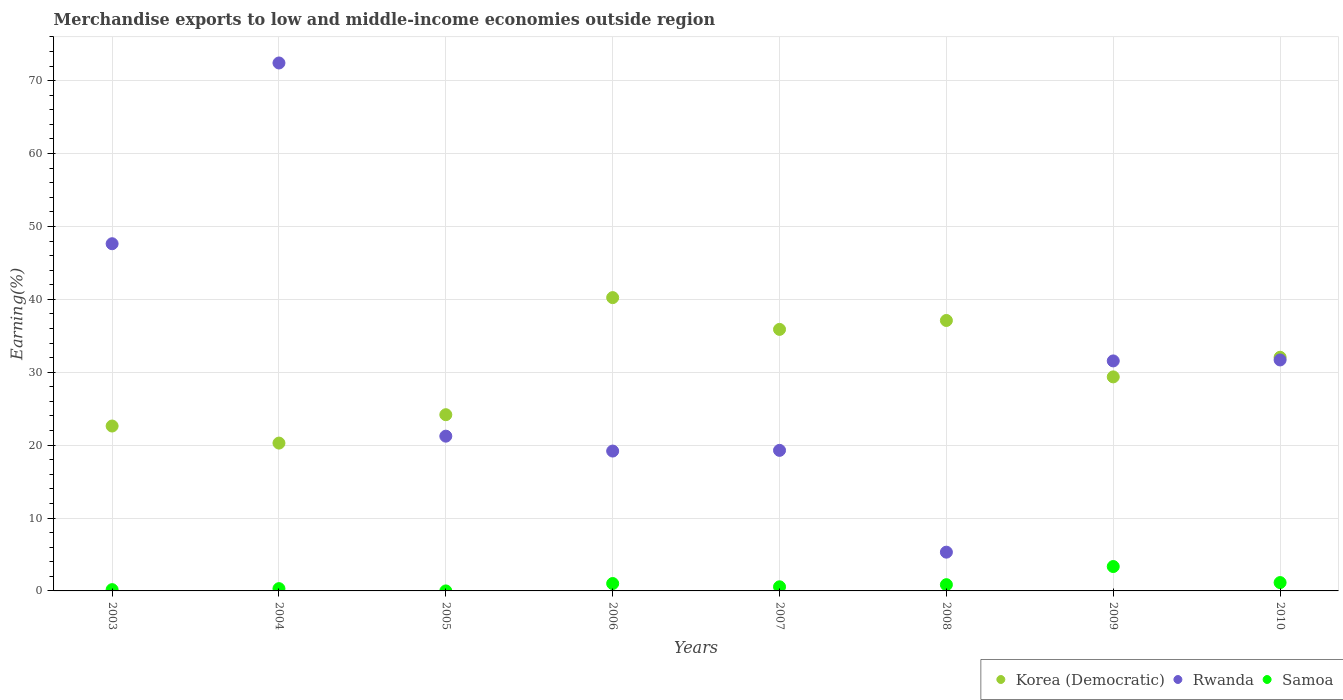How many different coloured dotlines are there?
Offer a very short reply. 3. Is the number of dotlines equal to the number of legend labels?
Give a very brief answer. Yes. What is the percentage of amount earned from merchandise exports in Samoa in 2008?
Give a very brief answer. 0.86. Across all years, what is the maximum percentage of amount earned from merchandise exports in Rwanda?
Offer a very short reply. 72.42. Across all years, what is the minimum percentage of amount earned from merchandise exports in Samoa?
Ensure brevity in your answer.  4.29047548765544e-6. In which year was the percentage of amount earned from merchandise exports in Korea (Democratic) maximum?
Give a very brief answer. 2006. In which year was the percentage of amount earned from merchandise exports in Korea (Democratic) minimum?
Offer a terse response. 2004. What is the total percentage of amount earned from merchandise exports in Samoa in the graph?
Provide a short and direct response. 7.41. What is the difference between the percentage of amount earned from merchandise exports in Rwanda in 2004 and that in 2008?
Make the answer very short. 67.11. What is the difference between the percentage of amount earned from merchandise exports in Samoa in 2004 and the percentage of amount earned from merchandise exports in Korea (Democratic) in 2007?
Your answer should be compact. -35.56. What is the average percentage of amount earned from merchandise exports in Korea (Democratic) per year?
Keep it short and to the point. 30.21. In the year 2006, what is the difference between the percentage of amount earned from merchandise exports in Samoa and percentage of amount earned from merchandise exports in Rwanda?
Your answer should be compact. -18.17. What is the ratio of the percentage of amount earned from merchandise exports in Rwanda in 2005 to that in 2007?
Your answer should be compact. 1.1. Is the percentage of amount earned from merchandise exports in Korea (Democratic) in 2003 less than that in 2010?
Your answer should be compact. Yes. Is the difference between the percentage of amount earned from merchandise exports in Samoa in 2005 and 2010 greater than the difference between the percentage of amount earned from merchandise exports in Rwanda in 2005 and 2010?
Your response must be concise. Yes. What is the difference between the highest and the second highest percentage of amount earned from merchandise exports in Korea (Democratic)?
Provide a short and direct response. 3.14. What is the difference between the highest and the lowest percentage of amount earned from merchandise exports in Rwanda?
Your answer should be compact. 67.11. In how many years, is the percentage of amount earned from merchandise exports in Korea (Democratic) greater than the average percentage of amount earned from merchandise exports in Korea (Democratic) taken over all years?
Offer a very short reply. 4. Is the percentage of amount earned from merchandise exports in Korea (Democratic) strictly greater than the percentage of amount earned from merchandise exports in Rwanda over the years?
Your answer should be compact. No. Is the percentage of amount earned from merchandise exports in Rwanda strictly less than the percentage of amount earned from merchandise exports in Samoa over the years?
Provide a short and direct response. No. Does the graph contain any zero values?
Give a very brief answer. No. Does the graph contain grids?
Ensure brevity in your answer.  Yes. How are the legend labels stacked?
Offer a terse response. Horizontal. What is the title of the graph?
Make the answer very short. Merchandise exports to low and middle-income economies outside region. Does "Malawi" appear as one of the legend labels in the graph?
Your answer should be compact. No. What is the label or title of the X-axis?
Provide a succinct answer. Years. What is the label or title of the Y-axis?
Your answer should be compact. Earning(%). What is the Earning(%) in Korea (Democratic) in 2003?
Offer a very short reply. 22.62. What is the Earning(%) of Rwanda in 2003?
Provide a short and direct response. 47.63. What is the Earning(%) of Samoa in 2003?
Your response must be concise. 0.18. What is the Earning(%) of Korea (Democratic) in 2004?
Make the answer very short. 20.28. What is the Earning(%) of Rwanda in 2004?
Provide a short and direct response. 72.42. What is the Earning(%) of Samoa in 2004?
Give a very brief answer. 0.31. What is the Earning(%) of Korea (Democratic) in 2005?
Provide a short and direct response. 24.17. What is the Earning(%) in Rwanda in 2005?
Ensure brevity in your answer.  21.23. What is the Earning(%) in Samoa in 2005?
Ensure brevity in your answer.  4.29047548765544e-6. What is the Earning(%) of Korea (Democratic) in 2006?
Your response must be concise. 40.24. What is the Earning(%) in Rwanda in 2006?
Provide a succinct answer. 19.19. What is the Earning(%) of Samoa in 2006?
Your answer should be compact. 1.01. What is the Earning(%) in Korea (Democratic) in 2007?
Make the answer very short. 35.88. What is the Earning(%) of Rwanda in 2007?
Give a very brief answer. 19.28. What is the Earning(%) in Samoa in 2007?
Ensure brevity in your answer.  0.57. What is the Earning(%) in Korea (Democratic) in 2008?
Your response must be concise. 37.1. What is the Earning(%) of Rwanda in 2008?
Make the answer very short. 5.32. What is the Earning(%) in Samoa in 2008?
Ensure brevity in your answer.  0.86. What is the Earning(%) of Korea (Democratic) in 2009?
Keep it short and to the point. 29.36. What is the Earning(%) of Rwanda in 2009?
Ensure brevity in your answer.  31.55. What is the Earning(%) of Samoa in 2009?
Ensure brevity in your answer.  3.35. What is the Earning(%) in Korea (Democratic) in 2010?
Provide a short and direct response. 32.05. What is the Earning(%) in Rwanda in 2010?
Offer a very short reply. 31.68. What is the Earning(%) in Samoa in 2010?
Make the answer very short. 1.14. Across all years, what is the maximum Earning(%) in Korea (Democratic)?
Offer a terse response. 40.24. Across all years, what is the maximum Earning(%) of Rwanda?
Offer a terse response. 72.42. Across all years, what is the maximum Earning(%) of Samoa?
Give a very brief answer. 3.35. Across all years, what is the minimum Earning(%) of Korea (Democratic)?
Offer a very short reply. 20.28. Across all years, what is the minimum Earning(%) in Rwanda?
Ensure brevity in your answer.  5.32. Across all years, what is the minimum Earning(%) in Samoa?
Keep it short and to the point. 4.29047548765544e-6. What is the total Earning(%) of Korea (Democratic) in the graph?
Make the answer very short. 241.7. What is the total Earning(%) of Rwanda in the graph?
Keep it short and to the point. 248.3. What is the total Earning(%) of Samoa in the graph?
Give a very brief answer. 7.41. What is the difference between the Earning(%) in Korea (Democratic) in 2003 and that in 2004?
Make the answer very short. 2.34. What is the difference between the Earning(%) of Rwanda in 2003 and that in 2004?
Offer a terse response. -24.8. What is the difference between the Earning(%) in Samoa in 2003 and that in 2004?
Provide a succinct answer. -0.14. What is the difference between the Earning(%) in Korea (Democratic) in 2003 and that in 2005?
Give a very brief answer. -1.55. What is the difference between the Earning(%) in Rwanda in 2003 and that in 2005?
Give a very brief answer. 26.4. What is the difference between the Earning(%) in Samoa in 2003 and that in 2005?
Provide a short and direct response. 0.18. What is the difference between the Earning(%) of Korea (Democratic) in 2003 and that in 2006?
Your answer should be compact. -17.62. What is the difference between the Earning(%) of Rwanda in 2003 and that in 2006?
Provide a short and direct response. 28.44. What is the difference between the Earning(%) in Samoa in 2003 and that in 2006?
Give a very brief answer. -0.84. What is the difference between the Earning(%) of Korea (Democratic) in 2003 and that in 2007?
Give a very brief answer. -13.26. What is the difference between the Earning(%) of Rwanda in 2003 and that in 2007?
Offer a terse response. 28.35. What is the difference between the Earning(%) of Samoa in 2003 and that in 2007?
Offer a very short reply. -0.39. What is the difference between the Earning(%) in Korea (Democratic) in 2003 and that in 2008?
Make the answer very short. -14.48. What is the difference between the Earning(%) of Rwanda in 2003 and that in 2008?
Give a very brief answer. 42.31. What is the difference between the Earning(%) in Samoa in 2003 and that in 2008?
Your response must be concise. -0.68. What is the difference between the Earning(%) in Korea (Democratic) in 2003 and that in 2009?
Make the answer very short. -6.74. What is the difference between the Earning(%) in Rwanda in 2003 and that in 2009?
Keep it short and to the point. 16.08. What is the difference between the Earning(%) in Samoa in 2003 and that in 2009?
Provide a short and direct response. -3.17. What is the difference between the Earning(%) of Korea (Democratic) in 2003 and that in 2010?
Your answer should be compact. -9.43. What is the difference between the Earning(%) of Rwanda in 2003 and that in 2010?
Offer a very short reply. 15.94. What is the difference between the Earning(%) of Samoa in 2003 and that in 2010?
Provide a succinct answer. -0.97. What is the difference between the Earning(%) of Korea (Democratic) in 2004 and that in 2005?
Your answer should be very brief. -3.89. What is the difference between the Earning(%) of Rwanda in 2004 and that in 2005?
Your response must be concise. 51.19. What is the difference between the Earning(%) in Samoa in 2004 and that in 2005?
Ensure brevity in your answer.  0.31. What is the difference between the Earning(%) in Korea (Democratic) in 2004 and that in 2006?
Keep it short and to the point. -19.96. What is the difference between the Earning(%) in Rwanda in 2004 and that in 2006?
Your response must be concise. 53.24. What is the difference between the Earning(%) in Samoa in 2004 and that in 2006?
Ensure brevity in your answer.  -0.7. What is the difference between the Earning(%) in Korea (Democratic) in 2004 and that in 2007?
Your answer should be very brief. -15.6. What is the difference between the Earning(%) in Rwanda in 2004 and that in 2007?
Keep it short and to the point. 53.14. What is the difference between the Earning(%) in Samoa in 2004 and that in 2007?
Offer a terse response. -0.25. What is the difference between the Earning(%) of Korea (Democratic) in 2004 and that in 2008?
Give a very brief answer. -16.82. What is the difference between the Earning(%) of Rwanda in 2004 and that in 2008?
Give a very brief answer. 67.11. What is the difference between the Earning(%) in Samoa in 2004 and that in 2008?
Keep it short and to the point. -0.54. What is the difference between the Earning(%) of Korea (Democratic) in 2004 and that in 2009?
Ensure brevity in your answer.  -9.08. What is the difference between the Earning(%) in Rwanda in 2004 and that in 2009?
Make the answer very short. 40.87. What is the difference between the Earning(%) in Samoa in 2004 and that in 2009?
Make the answer very short. -3.03. What is the difference between the Earning(%) in Korea (Democratic) in 2004 and that in 2010?
Provide a short and direct response. -11.77. What is the difference between the Earning(%) in Rwanda in 2004 and that in 2010?
Provide a short and direct response. 40.74. What is the difference between the Earning(%) in Samoa in 2004 and that in 2010?
Make the answer very short. -0.83. What is the difference between the Earning(%) in Korea (Democratic) in 2005 and that in 2006?
Your response must be concise. -16.06. What is the difference between the Earning(%) of Rwanda in 2005 and that in 2006?
Keep it short and to the point. 2.04. What is the difference between the Earning(%) of Samoa in 2005 and that in 2006?
Keep it short and to the point. -1.01. What is the difference between the Earning(%) of Korea (Democratic) in 2005 and that in 2007?
Ensure brevity in your answer.  -11.7. What is the difference between the Earning(%) in Rwanda in 2005 and that in 2007?
Provide a short and direct response. 1.95. What is the difference between the Earning(%) of Samoa in 2005 and that in 2007?
Provide a succinct answer. -0.57. What is the difference between the Earning(%) of Korea (Democratic) in 2005 and that in 2008?
Your response must be concise. -12.93. What is the difference between the Earning(%) in Rwanda in 2005 and that in 2008?
Make the answer very short. 15.91. What is the difference between the Earning(%) of Samoa in 2005 and that in 2008?
Provide a short and direct response. -0.86. What is the difference between the Earning(%) of Korea (Democratic) in 2005 and that in 2009?
Provide a short and direct response. -5.19. What is the difference between the Earning(%) of Rwanda in 2005 and that in 2009?
Your response must be concise. -10.32. What is the difference between the Earning(%) of Samoa in 2005 and that in 2009?
Give a very brief answer. -3.35. What is the difference between the Earning(%) of Korea (Democratic) in 2005 and that in 2010?
Make the answer very short. -7.88. What is the difference between the Earning(%) in Rwanda in 2005 and that in 2010?
Your response must be concise. -10.46. What is the difference between the Earning(%) in Samoa in 2005 and that in 2010?
Offer a terse response. -1.14. What is the difference between the Earning(%) of Korea (Democratic) in 2006 and that in 2007?
Ensure brevity in your answer.  4.36. What is the difference between the Earning(%) in Rwanda in 2006 and that in 2007?
Offer a very short reply. -0.1. What is the difference between the Earning(%) of Samoa in 2006 and that in 2007?
Provide a short and direct response. 0.45. What is the difference between the Earning(%) in Korea (Democratic) in 2006 and that in 2008?
Ensure brevity in your answer.  3.14. What is the difference between the Earning(%) in Rwanda in 2006 and that in 2008?
Offer a terse response. 13.87. What is the difference between the Earning(%) of Samoa in 2006 and that in 2008?
Provide a short and direct response. 0.16. What is the difference between the Earning(%) in Korea (Democratic) in 2006 and that in 2009?
Offer a terse response. 10.87. What is the difference between the Earning(%) in Rwanda in 2006 and that in 2009?
Ensure brevity in your answer.  -12.37. What is the difference between the Earning(%) of Samoa in 2006 and that in 2009?
Your answer should be compact. -2.33. What is the difference between the Earning(%) of Korea (Democratic) in 2006 and that in 2010?
Offer a very short reply. 8.19. What is the difference between the Earning(%) of Rwanda in 2006 and that in 2010?
Give a very brief answer. -12.5. What is the difference between the Earning(%) in Samoa in 2006 and that in 2010?
Your answer should be compact. -0.13. What is the difference between the Earning(%) in Korea (Democratic) in 2007 and that in 2008?
Provide a short and direct response. -1.22. What is the difference between the Earning(%) of Rwanda in 2007 and that in 2008?
Make the answer very short. 13.96. What is the difference between the Earning(%) in Samoa in 2007 and that in 2008?
Your answer should be compact. -0.29. What is the difference between the Earning(%) in Korea (Democratic) in 2007 and that in 2009?
Make the answer very short. 6.52. What is the difference between the Earning(%) in Rwanda in 2007 and that in 2009?
Give a very brief answer. -12.27. What is the difference between the Earning(%) in Samoa in 2007 and that in 2009?
Provide a succinct answer. -2.78. What is the difference between the Earning(%) in Korea (Democratic) in 2007 and that in 2010?
Offer a very short reply. 3.83. What is the difference between the Earning(%) of Rwanda in 2007 and that in 2010?
Your answer should be very brief. -12.4. What is the difference between the Earning(%) in Samoa in 2007 and that in 2010?
Offer a very short reply. -0.58. What is the difference between the Earning(%) in Korea (Democratic) in 2008 and that in 2009?
Give a very brief answer. 7.74. What is the difference between the Earning(%) of Rwanda in 2008 and that in 2009?
Provide a succinct answer. -26.23. What is the difference between the Earning(%) of Samoa in 2008 and that in 2009?
Give a very brief answer. -2.49. What is the difference between the Earning(%) of Korea (Democratic) in 2008 and that in 2010?
Keep it short and to the point. 5.05. What is the difference between the Earning(%) in Rwanda in 2008 and that in 2010?
Make the answer very short. -26.37. What is the difference between the Earning(%) of Samoa in 2008 and that in 2010?
Provide a succinct answer. -0.29. What is the difference between the Earning(%) of Korea (Democratic) in 2009 and that in 2010?
Your response must be concise. -2.69. What is the difference between the Earning(%) of Rwanda in 2009 and that in 2010?
Make the answer very short. -0.13. What is the difference between the Earning(%) in Samoa in 2009 and that in 2010?
Provide a short and direct response. 2.2. What is the difference between the Earning(%) of Korea (Democratic) in 2003 and the Earning(%) of Rwanda in 2004?
Your answer should be very brief. -49.8. What is the difference between the Earning(%) in Korea (Democratic) in 2003 and the Earning(%) in Samoa in 2004?
Offer a terse response. 22.31. What is the difference between the Earning(%) of Rwanda in 2003 and the Earning(%) of Samoa in 2004?
Keep it short and to the point. 47.31. What is the difference between the Earning(%) in Korea (Democratic) in 2003 and the Earning(%) in Rwanda in 2005?
Your answer should be compact. 1.39. What is the difference between the Earning(%) in Korea (Democratic) in 2003 and the Earning(%) in Samoa in 2005?
Your response must be concise. 22.62. What is the difference between the Earning(%) in Rwanda in 2003 and the Earning(%) in Samoa in 2005?
Your response must be concise. 47.63. What is the difference between the Earning(%) of Korea (Democratic) in 2003 and the Earning(%) of Rwanda in 2006?
Provide a short and direct response. 3.43. What is the difference between the Earning(%) in Korea (Democratic) in 2003 and the Earning(%) in Samoa in 2006?
Offer a very short reply. 21.61. What is the difference between the Earning(%) of Rwanda in 2003 and the Earning(%) of Samoa in 2006?
Your response must be concise. 46.61. What is the difference between the Earning(%) of Korea (Democratic) in 2003 and the Earning(%) of Rwanda in 2007?
Your answer should be compact. 3.34. What is the difference between the Earning(%) in Korea (Democratic) in 2003 and the Earning(%) in Samoa in 2007?
Offer a terse response. 22.05. What is the difference between the Earning(%) in Rwanda in 2003 and the Earning(%) in Samoa in 2007?
Your answer should be very brief. 47.06. What is the difference between the Earning(%) of Korea (Democratic) in 2003 and the Earning(%) of Rwanda in 2008?
Ensure brevity in your answer.  17.3. What is the difference between the Earning(%) of Korea (Democratic) in 2003 and the Earning(%) of Samoa in 2008?
Offer a very short reply. 21.76. What is the difference between the Earning(%) of Rwanda in 2003 and the Earning(%) of Samoa in 2008?
Provide a succinct answer. 46.77. What is the difference between the Earning(%) of Korea (Democratic) in 2003 and the Earning(%) of Rwanda in 2009?
Provide a succinct answer. -8.93. What is the difference between the Earning(%) in Korea (Democratic) in 2003 and the Earning(%) in Samoa in 2009?
Your answer should be compact. 19.27. What is the difference between the Earning(%) of Rwanda in 2003 and the Earning(%) of Samoa in 2009?
Make the answer very short. 44.28. What is the difference between the Earning(%) of Korea (Democratic) in 2003 and the Earning(%) of Rwanda in 2010?
Your response must be concise. -9.06. What is the difference between the Earning(%) in Korea (Democratic) in 2003 and the Earning(%) in Samoa in 2010?
Your response must be concise. 21.48. What is the difference between the Earning(%) of Rwanda in 2003 and the Earning(%) of Samoa in 2010?
Your response must be concise. 46.48. What is the difference between the Earning(%) in Korea (Democratic) in 2004 and the Earning(%) in Rwanda in 2005?
Provide a short and direct response. -0.95. What is the difference between the Earning(%) in Korea (Democratic) in 2004 and the Earning(%) in Samoa in 2005?
Provide a short and direct response. 20.28. What is the difference between the Earning(%) of Rwanda in 2004 and the Earning(%) of Samoa in 2005?
Make the answer very short. 72.42. What is the difference between the Earning(%) in Korea (Democratic) in 2004 and the Earning(%) in Rwanda in 2006?
Provide a succinct answer. 1.09. What is the difference between the Earning(%) in Korea (Democratic) in 2004 and the Earning(%) in Samoa in 2006?
Ensure brevity in your answer.  19.27. What is the difference between the Earning(%) of Rwanda in 2004 and the Earning(%) of Samoa in 2006?
Your answer should be very brief. 71.41. What is the difference between the Earning(%) of Korea (Democratic) in 2004 and the Earning(%) of Rwanda in 2007?
Offer a terse response. 1. What is the difference between the Earning(%) in Korea (Democratic) in 2004 and the Earning(%) in Samoa in 2007?
Your response must be concise. 19.71. What is the difference between the Earning(%) of Rwanda in 2004 and the Earning(%) of Samoa in 2007?
Provide a succinct answer. 71.86. What is the difference between the Earning(%) in Korea (Democratic) in 2004 and the Earning(%) in Rwanda in 2008?
Your response must be concise. 14.96. What is the difference between the Earning(%) of Korea (Democratic) in 2004 and the Earning(%) of Samoa in 2008?
Provide a succinct answer. 19.42. What is the difference between the Earning(%) of Rwanda in 2004 and the Earning(%) of Samoa in 2008?
Make the answer very short. 71.57. What is the difference between the Earning(%) of Korea (Democratic) in 2004 and the Earning(%) of Rwanda in 2009?
Provide a succinct answer. -11.27. What is the difference between the Earning(%) in Korea (Democratic) in 2004 and the Earning(%) in Samoa in 2009?
Make the answer very short. 16.93. What is the difference between the Earning(%) in Rwanda in 2004 and the Earning(%) in Samoa in 2009?
Keep it short and to the point. 69.08. What is the difference between the Earning(%) of Korea (Democratic) in 2004 and the Earning(%) of Rwanda in 2010?
Make the answer very short. -11.41. What is the difference between the Earning(%) of Korea (Democratic) in 2004 and the Earning(%) of Samoa in 2010?
Ensure brevity in your answer.  19.13. What is the difference between the Earning(%) in Rwanda in 2004 and the Earning(%) in Samoa in 2010?
Ensure brevity in your answer.  71.28. What is the difference between the Earning(%) of Korea (Democratic) in 2005 and the Earning(%) of Rwanda in 2006?
Offer a terse response. 4.99. What is the difference between the Earning(%) in Korea (Democratic) in 2005 and the Earning(%) in Samoa in 2006?
Keep it short and to the point. 23.16. What is the difference between the Earning(%) in Rwanda in 2005 and the Earning(%) in Samoa in 2006?
Your answer should be very brief. 20.22. What is the difference between the Earning(%) in Korea (Democratic) in 2005 and the Earning(%) in Rwanda in 2007?
Make the answer very short. 4.89. What is the difference between the Earning(%) in Korea (Democratic) in 2005 and the Earning(%) in Samoa in 2007?
Make the answer very short. 23.61. What is the difference between the Earning(%) in Rwanda in 2005 and the Earning(%) in Samoa in 2007?
Make the answer very short. 20.66. What is the difference between the Earning(%) of Korea (Democratic) in 2005 and the Earning(%) of Rwanda in 2008?
Your answer should be very brief. 18.86. What is the difference between the Earning(%) of Korea (Democratic) in 2005 and the Earning(%) of Samoa in 2008?
Make the answer very short. 23.32. What is the difference between the Earning(%) in Rwanda in 2005 and the Earning(%) in Samoa in 2008?
Your answer should be very brief. 20.37. What is the difference between the Earning(%) in Korea (Democratic) in 2005 and the Earning(%) in Rwanda in 2009?
Give a very brief answer. -7.38. What is the difference between the Earning(%) of Korea (Democratic) in 2005 and the Earning(%) of Samoa in 2009?
Make the answer very short. 20.83. What is the difference between the Earning(%) of Rwanda in 2005 and the Earning(%) of Samoa in 2009?
Keep it short and to the point. 17.88. What is the difference between the Earning(%) in Korea (Democratic) in 2005 and the Earning(%) in Rwanda in 2010?
Make the answer very short. -7.51. What is the difference between the Earning(%) in Korea (Democratic) in 2005 and the Earning(%) in Samoa in 2010?
Make the answer very short. 23.03. What is the difference between the Earning(%) in Rwanda in 2005 and the Earning(%) in Samoa in 2010?
Offer a very short reply. 20.09. What is the difference between the Earning(%) of Korea (Democratic) in 2006 and the Earning(%) of Rwanda in 2007?
Make the answer very short. 20.95. What is the difference between the Earning(%) of Korea (Democratic) in 2006 and the Earning(%) of Samoa in 2007?
Offer a very short reply. 39.67. What is the difference between the Earning(%) in Rwanda in 2006 and the Earning(%) in Samoa in 2007?
Keep it short and to the point. 18.62. What is the difference between the Earning(%) of Korea (Democratic) in 2006 and the Earning(%) of Rwanda in 2008?
Provide a succinct answer. 34.92. What is the difference between the Earning(%) of Korea (Democratic) in 2006 and the Earning(%) of Samoa in 2008?
Provide a succinct answer. 39.38. What is the difference between the Earning(%) in Rwanda in 2006 and the Earning(%) in Samoa in 2008?
Ensure brevity in your answer.  18.33. What is the difference between the Earning(%) in Korea (Democratic) in 2006 and the Earning(%) in Rwanda in 2009?
Ensure brevity in your answer.  8.68. What is the difference between the Earning(%) in Korea (Democratic) in 2006 and the Earning(%) in Samoa in 2009?
Your answer should be compact. 36.89. What is the difference between the Earning(%) in Rwanda in 2006 and the Earning(%) in Samoa in 2009?
Make the answer very short. 15.84. What is the difference between the Earning(%) of Korea (Democratic) in 2006 and the Earning(%) of Rwanda in 2010?
Make the answer very short. 8.55. What is the difference between the Earning(%) of Korea (Democratic) in 2006 and the Earning(%) of Samoa in 2010?
Your answer should be very brief. 39.09. What is the difference between the Earning(%) of Rwanda in 2006 and the Earning(%) of Samoa in 2010?
Provide a short and direct response. 18.04. What is the difference between the Earning(%) of Korea (Democratic) in 2007 and the Earning(%) of Rwanda in 2008?
Your answer should be compact. 30.56. What is the difference between the Earning(%) of Korea (Democratic) in 2007 and the Earning(%) of Samoa in 2008?
Make the answer very short. 35.02. What is the difference between the Earning(%) of Rwanda in 2007 and the Earning(%) of Samoa in 2008?
Your response must be concise. 18.43. What is the difference between the Earning(%) of Korea (Democratic) in 2007 and the Earning(%) of Rwanda in 2009?
Keep it short and to the point. 4.33. What is the difference between the Earning(%) in Korea (Democratic) in 2007 and the Earning(%) in Samoa in 2009?
Offer a very short reply. 32.53. What is the difference between the Earning(%) in Rwanda in 2007 and the Earning(%) in Samoa in 2009?
Your answer should be compact. 15.94. What is the difference between the Earning(%) in Korea (Democratic) in 2007 and the Earning(%) in Rwanda in 2010?
Keep it short and to the point. 4.19. What is the difference between the Earning(%) in Korea (Democratic) in 2007 and the Earning(%) in Samoa in 2010?
Your answer should be very brief. 34.73. What is the difference between the Earning(%) in Rwanda in 2007 and the Earning(%) in Samoa in 2010?
Ensure brevity in your answer.  18.14. What is the difference between the Earning(%) in Korea (Democratic) in 2008 and the Earning(%) in Rwanda in 2009?
Your answer should be compact. 5.55. What is the difference between the Earning(%) in Korea (Democratic) in 2008 and the Earning(%) in Samoa in 2009?
Your answer should be compact. 33.75. What is the difference between the Earning(%) of Rwanda in 2008 and the Earning(%) of Samoa in 2009?
Give a very brief answer. 1.97. What is the difference between the Earning(%) of Korea (Democratic) in 2008 and the Earning(%) of Rwanda in 2010?
Make the answer very short. 5.42. What is the difference between the Earning(%) of Korea (Democratic) in 2008 and the Earning(%) of Samoa in 2010?
Ensure brevity in your answer.  35.96. What is the difference between the Earning(%) in Rwanda in 2008 and the Earning(%) in Samoa in 2010?
Offer a very short reply. 4.17. What is the difference between the Earning(%) of Korea (Democratic) in 2009 and the Earning(%) of Rwanda in 2010?
Give a very brief answer. -2.32. What is the difference between the Earning(%) of Korea (Democratic) in 2009 and the Earning(%) of Samoa in 2010?
Your answer should be very brief. 28.22. What is the difference between the Earning(%) in Rwanda in 2009 and the Earning(%) in Samoa in 2010?
Your answer should be compact. 30.41. What is the average Earning(%) in Korea (Democratic) per year?
Your response must be concise. 30.21. What is the average Earning(%) of Rwanda per year?
Offer a very short reply. 31.04. What is the average Earning(%) of Samoa per year?
Offer a terse response. 0.93. In the year 2003, what is the difference between the Earning(%) of Korea (Democratic) and Earning(%) of Rwanda?
Make the answer very short. -25.01. In the year 2003, what is the difference between the Earning(%) in Korea (Democratic) and Earning(%) in Samoa?
Provide a succinct answer. 22.44. In the year 2003, what is the difference between the Earning(%) in Rwanda and Earning(%) in Samoa?
Provide a short and direct response. 47.45. In the year 2004, what is the difference between the Earning(%) in Korea (Democratic) and Earning(%) in Rwanda?
Provide a succinct answer. -52.14. In the year 2004, what is the difference between the Earning(%) in Korea (Democratic) and Earning(%) in Samoa?
Ensure brevity in your answer.  19.97. In the year 2004, what is the difference between the Earning(%) of Rwanda and Earning(%) of Samoa?
Your answer should be very brief. 72.11. In the year 2005, what is the difference between the Earning(%) in Korea (Democratic) and Earning(%) in Rwanda?
Provide a succinct answer. 2.94. In the year 2005, what is the difference between the Earning(%) in Korea (Democratic) and Earning(%) in Samoa?
Give a very brief answer. 24.17. In the year 2005, what is the difference between the Earning(%) of Rwanda and Earning(%) of Samoa?
Provide a succinct answer. 21.23. In the year 2006, what is the difference between the Earning(%) in Korea (Democratic) and Earning(%) in Rwanda?
Offer a terse response. 21.05. In the year 2006, what is the difference between the Earning(%) in Korea (Democratic) and Earning(%) in Samoa?
Provide a succinct answer. 39.22. In the year 2006, what is the difference between the Earning(%) in Rwanda and Earning(%) in Samoa?
Ensure brevity in your answer.  18.17. In the year 2007, what is the difference between the Earning(%) in Korea (Democratic) and Earning(%) in Rwanda?
Offer a very short reply. 16.6. In the year 2007, what is the difference between the Earning(%) in Korea (Democratic) and Earning(%) in Samoa?
Keep it short and to the point. 35.31. In the year 2007, what is the difference between the Earning(%) of Rwanda and Earning(%) of Samoa?
Provide a short and direct response. 18.72. In the year 2008, what is the difference between the Earning(%) in Korea (Democratic) and Earning(%) in Rwanda?
Offer a very short reply. 31.78. In the year 2008, what is the difference between the Earning(%) of Korea (Democratic) and Earning(%) of Samoa?
Your answer should be compact. 36.24. In the year 2008, what is the difference between the Earning(%) in Rwanda and Earning(%) in Samoa?
Offer a terse response. 4.46. In the year 2009, what is the difference between the Earning(%) in Korea (Democratic) and Earning(%) in Rwanda?
Provide a short and direct response. -2.19. In the year 2009, what is the difference between the Earning(%) in Korea (Democratic) and Earning(%) in Samoa?
Your response must be concise. 26.02. In the year 2009, what is the difference between the Earning(%) of Rwanda and Earning(%) of Samoa?
Your response must be concise. 28.21. In the year 2010, what is the difference between the Earning(%) in Korea (Democratic) and Earning(%) in Rwanda?
Keep it short and to the point. 0.37. In the year 2010, what is the difference between the Earning(%) in Korea (Democratic) and Earning(%) in Samoa?
Provide a short and direct response. 30.91. In the year 2010, what is the difference between the Earning(%) of Rwanda and Earning(%) of Samoa?
Provide a succinct answer. 30.54. What is the ratio of the Earning(%) in Korea (Democratic) in 2003 to that in 2004?
Provide a succinct answer. 1.12. What is the ratio of the Earning(%) in Rwanda in 2003 to that in 2004?
Give a very brief answer. 0.66. What is the ratio of the Earning(%) in Samoa in 2003 to that in 2004?
Offer a very short reply. 0.56. What is the ratio of the Earning(%) of Korea (Democratic) in 2003 to that in 2005?
Keep it short and to the point. 0.94. What is the ratio of the Earning(%) of Rwanda in 2003 to that in 2005?
Your answer should be compact. 2.24. What is the ratio of the Earning(%) of Samoa in 2003 to that in 2005?
Your response must be concise. 4.09e+04. What is the ratio of the Earning(%) of Korea (Democratic) in 2003 to that in 2006?
Make the answer very short. 0.56. What is the ratio of the Earning(%) of Rwanda in 2003 to that in 2006?
Your response must be concise. 2.48. What is the ratio of the Earning(%) in Samoa in 2003 to that in 2006?
Your answer should be compact. 0.17. What is the ratio of the Earning(%) of Korea (Democratic) in 2003 to that in 2007?
Ensure brevity in your answer.  0.63. What is the ratio of the Earning(%) of Rwanda in 2003 to that in 2007?
Your answer should be compact. 2.47. What is the ratio of the Earning(%) in Samoa in 2003 to that in 2007?
Ensure brevity in your answer.  0.31. What is the ratio of the Earning(%) in Korea (Democratic) in 2003 to that in 2008?
Make the answer very short. 0.61. What is the ratio of the Earning(%) in Rwanda in 2003 to that in 2008?
Make the answer very short. 8.96. What is the ratio of the Earning(%) of Samoa in 2003 to that in 2008?
Make the answer very short. 0.21. What is the ratio of the Earning(%) in Korea (Democratic) in 2003 to that in 2009?
Provide a short and direct response. 0.77. What is the ratio of the Earning(%) in Rwanda in 2003 to that in 2009?
Make the answer very short. 1.51. What is the ratio of the Earning(%) of Samoa in 2003 to that in 2009?
Your answer should be compact. 0.05. What is the ratio of the Earning(%) of Korea (Democratic) in 2003 to that in 2010?
Make the answer very short. 0.71. What is the ratio of the Earning(%) in Rwanda in 2003 to that in 2010?
Your response must be concise. 1.5. What is the ratio of the Earning(%) in Samoa in 2003 to that in 2010?
Ensure brevity in your answer.  0.15. What is the ratio of the Earning(%) of Korea (Democratic) in 2004 to that in 2005?
Your response must be concise. 0.84. What is the ratio of the Earning(%) of Rwanda in 2004 to that in 2005?
Your answer should be compact. 3.41. What is the ratio of the Earning(%) of Samoa in 2004 to that in 2005?
Give a very brief answer. 7.30e+04. What is the ratio of the Earning(%) in Korea (Democratic) in 2004 to that in 2006?
Keep it short and to the point. 0.5. What is the ratio of the Earning(%) in Rwanda in 2004 to that in 2006?
Your answer should be compact. 3.77. What is the ratio of the Earning(%) in Samoa in 2004 to that in 2006?
Your answer should be compact. 0.31. What is the ratio of the Earning(%) in Korea (Democratic) in 2004 to that in 2007?
Provide a short and direct response. 0.57. What is the ratio of the Earning(%) of Rwanda in 2004 to that in 2007?
Your response must be concise. 3.76. What is the ratio of the Earning(%) in Samoa in 2004 to that in 2007?
Offer a very short reply. 0.55. What is the ratio of the Earning(%) of Korea (Democratic) in 2004 to that in 2008?
Ensure brevity in your answer.  0.55. What is the ratio of the Earning(%) of Rwanda in 2004 to that in 2008?
Provide a short and direct response. 13.62. What is the ratio of the Earning(%) in Samoa in 2004 to that in 2008?
Provide a short and direct response. 0.37. What is the ratio of the Earning(%) of Korea (Democratic) in 2004 to that in 2009?
Provide a short and direct response. 0.69. What is the ratio of the Earning(%) in Rwanda in 2004 to that in 2009?
Ensure brevity in your answer.  2.3. What is the ratio of the Earning(%) of Samoa in 2004 to that in 2009?
Keep it short and to the point. 0.09. What is the ratio of the Earning(%) of Korea (Democratic) in 2004 to that in 2010?
Give a very brief answer. 0.63. What is the ratio of the Earning(%) of Rwanda in 2004 to that in 2010?
Offer a terse response. 2.29. What is the ratio of the Earning(%) in Samoa in 2004 to that in 2010?
Provide a short and direct response. 0.27. What is the ratio of the Earning(%) of Korea (Democratic) in 2005 to that in 2006?
Make the answer very short. 0.6. What is the ratio of the Earning(%) in Rwanda in 2005 to that in 2006?
Ensure brevity in your answer.  1.11. What is the ratio of the Earning(%) in Korea (Democratic) in 2005 to that in 2007?
Make the answer very short. 0.67. What is the ratio of the Earning(%) of Rwanda in 2005 to that in 2007?
Make the answer very short. 1.1. What is the ratio of the Earning(%) of Korea (Democratic) in 2005 to that in 2008?
Your answer should be compact. 0.65. What is the ratio of the Earning(%) of Rwanda in 2005 to that in 2008?
Keep it short and to the point. 3.99. What is the ratio of the Earning(%) of Samoa in 2005 to that in 2008?
Provide a short and direct response. 0. What is the ratio of the Earning(%) in Korea (Democratic) in 2005 to that in 2009?
Provide a succinct answer. 0.82. What is the ratio of the Earning(%) in Rwanda in 2005 to that in 2009?
Your answer should be compact. 0.67. What is the ratio of the Earning(%) in Korea (Democratic) in 2005 to that in 2010?
Your response must be concise. 0.75. What is the ratio of the Earning(%) of Rwanda in 2005 to that in 2010?
Offer a very short reply. 0.67. What is the ratio of the Earning(%) of Korea (Democratic) in 2006 to that in 2007?
Your response must be concise. 1.12. What is the ratio of the Earning(%) in Samoa in 2006 to that in 2007?
Your answer should be very brief. 1.79. What is the ratio of the Earning(%) of Korea (Democratic) in 2006 to that in 2008?
Make the answer very short. 1.08. What is the ratio of the Earning(%) of Rwanda in 2006 to that in 2008?
Provide a succinct answer. 3.61. What is the ratio of the Earning(%) of Samoa in 2006 to that in 2008?
Offer a terse response. 1.19. What is the ratio of the Earning(%) in Korea (Democratic) in 2006 to that in 2009?
Provide a succinct answer. 1.37. What is the ratio of the Earning(%) of Rwanda in 2006 to that in 2009?
Your response must be concise. 0.61. What is the ratio of the Earning(%) in Samoa in 2006 to that in 2009?
Offer a terse response. 0.3. What is the ratio of the Earning(%) in Korea (Democratic) in 2006 to that in 2010?
Your answer should be compact. 1.26. What is the ratio of the Earning(%) in Rwanda in 2006 to that in 2010?
Your answer should be compact. 0.61. What is the ratio of the Earning(%) of Samoa in 2006 to that in 2010?
Your response must be concise. 0.89. What is the ratio of the Earning(%) of Korea (Democratic) in 2007 to that in 2008?
Make the answer very short. 0.97. What is the ratio of the Earning(%) of Rwanda in 2007 to that in 2008?
Your answer should be compact. 3.63. What is the ratio of the Earning(%) in Samoa in 2007 to that in 2008?
Ensure brevity in your answer.  0.66. What is the ratio of the Earning(%) in Korea (Democratic) in 2007 to that in 2009?
Make the answer very short. 1.22. What is the ratio of the Earning(%) of Rwanda in 2007 to that in 2009?
Provide a short and direct response. 0.61. What is the ratio of the Earning(%) in Samoa in 2007 to that in 2009?
Your answer should be very brief. 0.17. What is the ratio of the Earning(%) in Korea (Democratic) in 2007 to that in 2010?
Give a very brief answer. 1.12. What is the ratio of the Earning(%) of Rwanda in 2007 to that in 2010?
Make the answer very short. 0.61. What is the ratio of the Earning(%) of Samoa in 2007 to that in 2010?
Make the answer very short. 0.49. What is the ratio of the Earning(%) of Korea (Democratic) in 2008 to that in 2009?
Make the answer very short. 1.26. What is the ratio of the Earning(%) of Rwanda in 2008 to that in 2009?
Ensure brevity in your answer.  0.17. What is the ratio of the Earning(%) of Samoa in 2008 to that in 2009?
Ensure brevity in your answer.  0.26. What is the ratio of the Earning(%) in Korea (Democratic) in 2008 to that in 2010?
Give a very brief answer. 1.16. What is the ratio of the Earning(%) in Rwanda in 2008 to that in 2010?
Offer a terse response. 0.17. What is the ratio of the Earning(%) of Samoa in 2008 to that in 2010?
Keep it short and to the point. 0.75. What is the ratio of the Earning(%) of Korea (Democratic) in 2009 to that in 2010?
Offer a terse response. 0.92. What is the ratio of the Earning(%) in Rwanda in 2009 to that in 2010?
Provide a short and direct response. 1. What is the ratio of the Earning(%) in Samoa in 2009 to that in 2010?
Keep it short and to the point. 2.92. What is the difference between the highest and the second highest Earning(%) of Korea (Democratic)?
Offer a terse response. 3.14. What is the difference between the highest and the second highest Earning(%) of Rwanda?
Offer a very short reply. 24.8. What is the difference between the highest and the second highest Earning(%) of Samoa?
Keep it short and to the point. 2.2. What is the difference between the highest and the lowest Earning(%) of Korea (Democratic)?
Your response must be concise. 19.96. What is the difference between the highest and the lowest Earning(%) of Rwanda?
Provide a succinct answer. 67.11. What is the difference between the highest and the lowest Earning(%) of Samoa?
Ensure brevity in your answer.  3.35. 